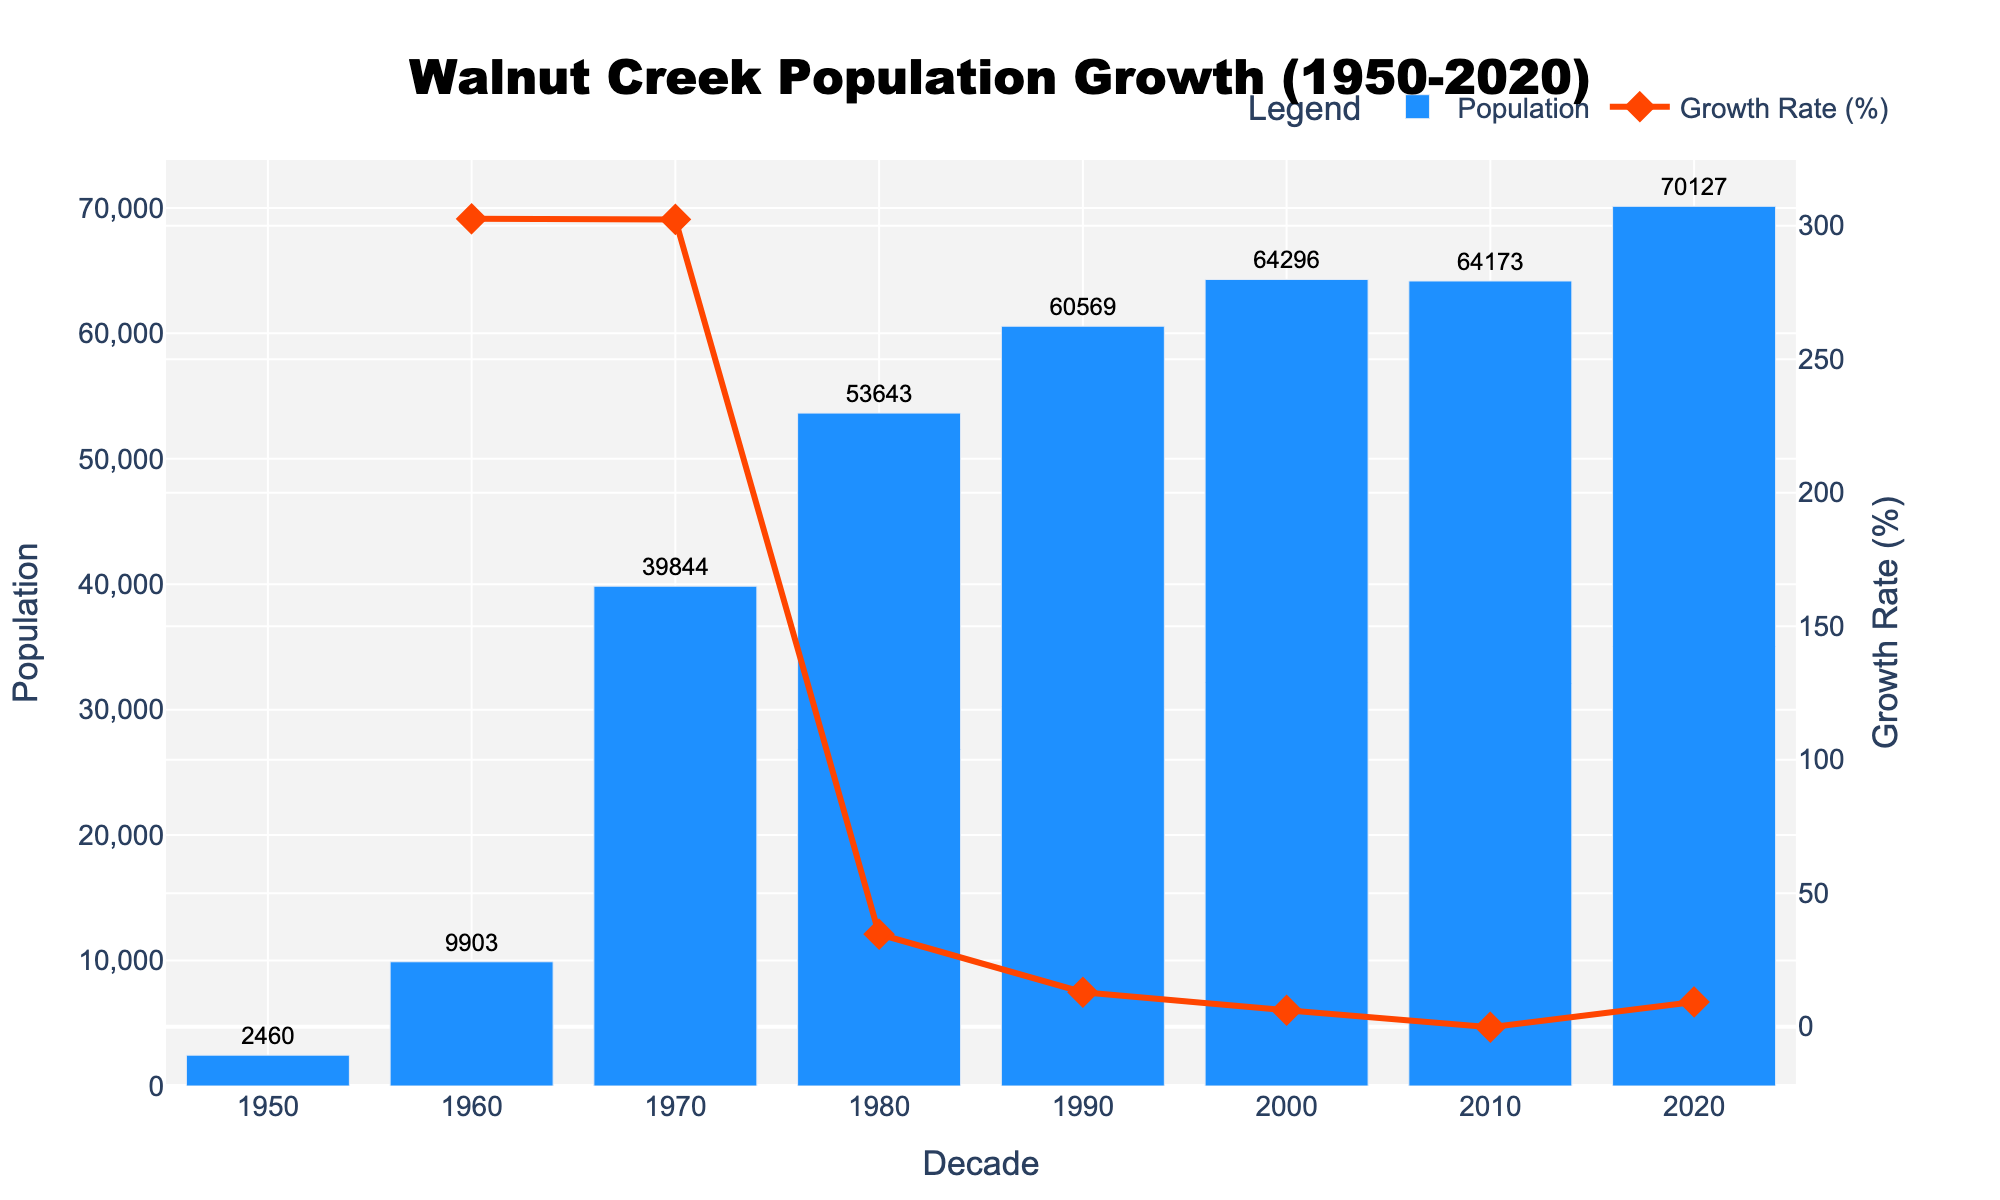What is the population of Walnut Creek in 1980? We look at the bar representing 1980 on the x-axis and note the population value displayed above it.
Answer: 53,643 What's the percentage growth rate from 1950 to 1960? We find the growth rate line that moves between 1950 and 1960. The value is displayed above the point connected by the line.
Answer: ~302.6% How did the population change between 2010 and 2020? Comparing the heights of the bars corresponding to 2010 and 2020, we note that the 2020 bar is taller than the one for 2010. Subtract the population of 2010 from that of 2020.
Answer: Increased by 5,954 When did Walnut Creek experience the highest growth rate, and what was it? Looking at the secondary y-axis (growth rate) line, determine the decade where the highest point occurs. The highest point is over the 1950-1960 interval.
Answer: 302.6% in the 1950s Which decade shows a negative or zero growth rate? Observe the line representing the growth rate; the only part dips below or reaches the zero line. This occurs between 2000 and 2010.
Answer: 2000-2010 What's the average population of Walnut Creek from 1950 to 2000? Sum the population numbers from 1950 to 2000 and divide by the number of decades (6). (2,460 + 9,903 + 39,844 + 53,643 + 60,569 + 64,296) / 6
Answer: 38,119 In which decade did Walnut Creek's population first exceed 50,000? Find the first bar whose height indicates a population greater than 50,000; this is between 1970 and 1980.
Answer: 1980 How many decades show a consistent population increase (compared to the previous decade)? Identify the number of consecutive bars that are consistently taller than the one before them. There are 5 increasing bars, indicating growth from 1950 through 1990.
Answer: 5 decades What color represents population in the bar chart? The bars representing population are uniformly colored; look at the bars' color.
Answer: Blue What is the smallest population recorded in the data set? Look for the shortest bar and note the population above it.
Answer: 2,460 (in 1950) 